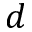Convert formula to latex. <formula><loc_0><loc_0><loc_500><loc_500>d</formula> 